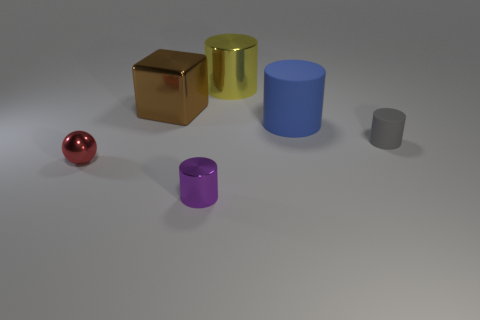Subtract all big metal cylinders. How many cylinders are left? 3 Subtract all purple cylinders. How many cylinders are left? 3 Add 2 small purple cylinders. How many objects exist? 8 Subtract all cylinders. How many objects are left? 2 Subtract all purple cubes. How many blue cylinders are left? 1 Subtract 0 yellow balls. How many objects are left? 6 Subtract all red cylinders. Subtract all gray balls. How many cylinders are left? 4 Subtract all gray matte cylinders. Subtract all small metallic spheres. How many objects are left? 4 Add 1 purple metal cylinders. How many purple metal cylinders are left? 2 Add 1 large red things. How many large red things exist? 1 